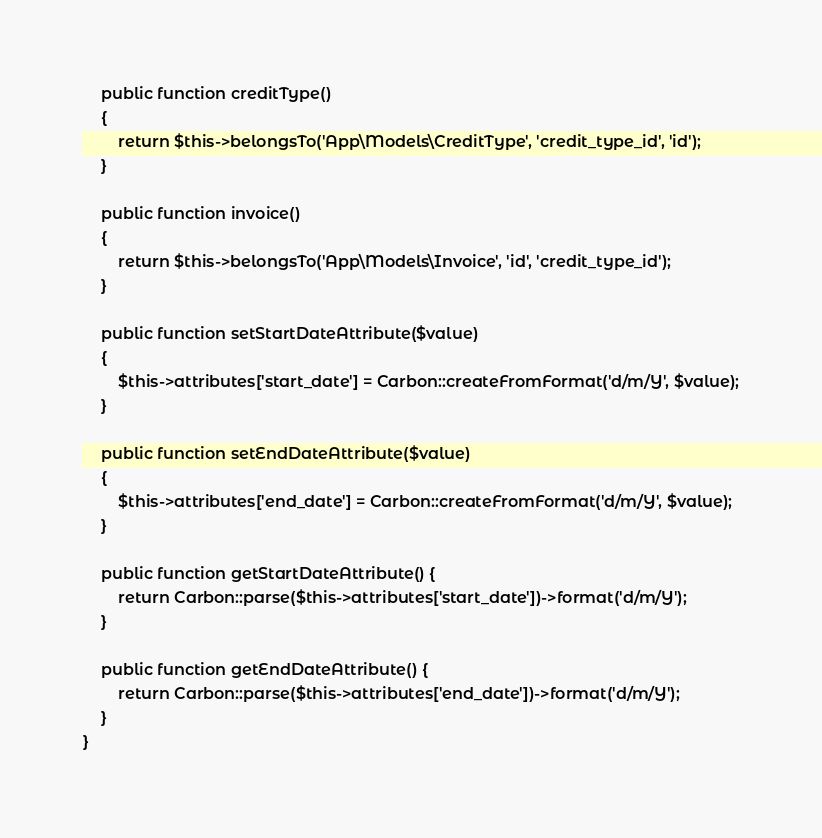Convert code to text. <code><loc_0><loc_0><loc_500><loc_500><_PHP_>
    public function creditType()
    {
        return $this->belongsTo('App\Models\CreditType', 'credit_type_id', 'id');
    }

    public function invoice()
    {
        return $this->belongsTo('App\Models\Invoice', 'id', 'credit_type_id');
    }

    public function setStartDateAttribute($value)
    {
        $this->attributes['start_date'] = Carbon::createFromFormat('d/m/Y', $value);
    }

    public function setEndDateAttribute($value)
    {
        $this->attributes['end_date'] = Carbon::createFromFormat('d/m/Y', $value);
    }

    public function getStartDateAttribute() {
        return Carbon::parse($this->attributes['start_date'])->format('d/m/Y');
    }

    public function getEndDateAttribute() {
        return Carbon::parse($this->attributes['end_date'])->format('d/m/Y');
    }
}
</code> 